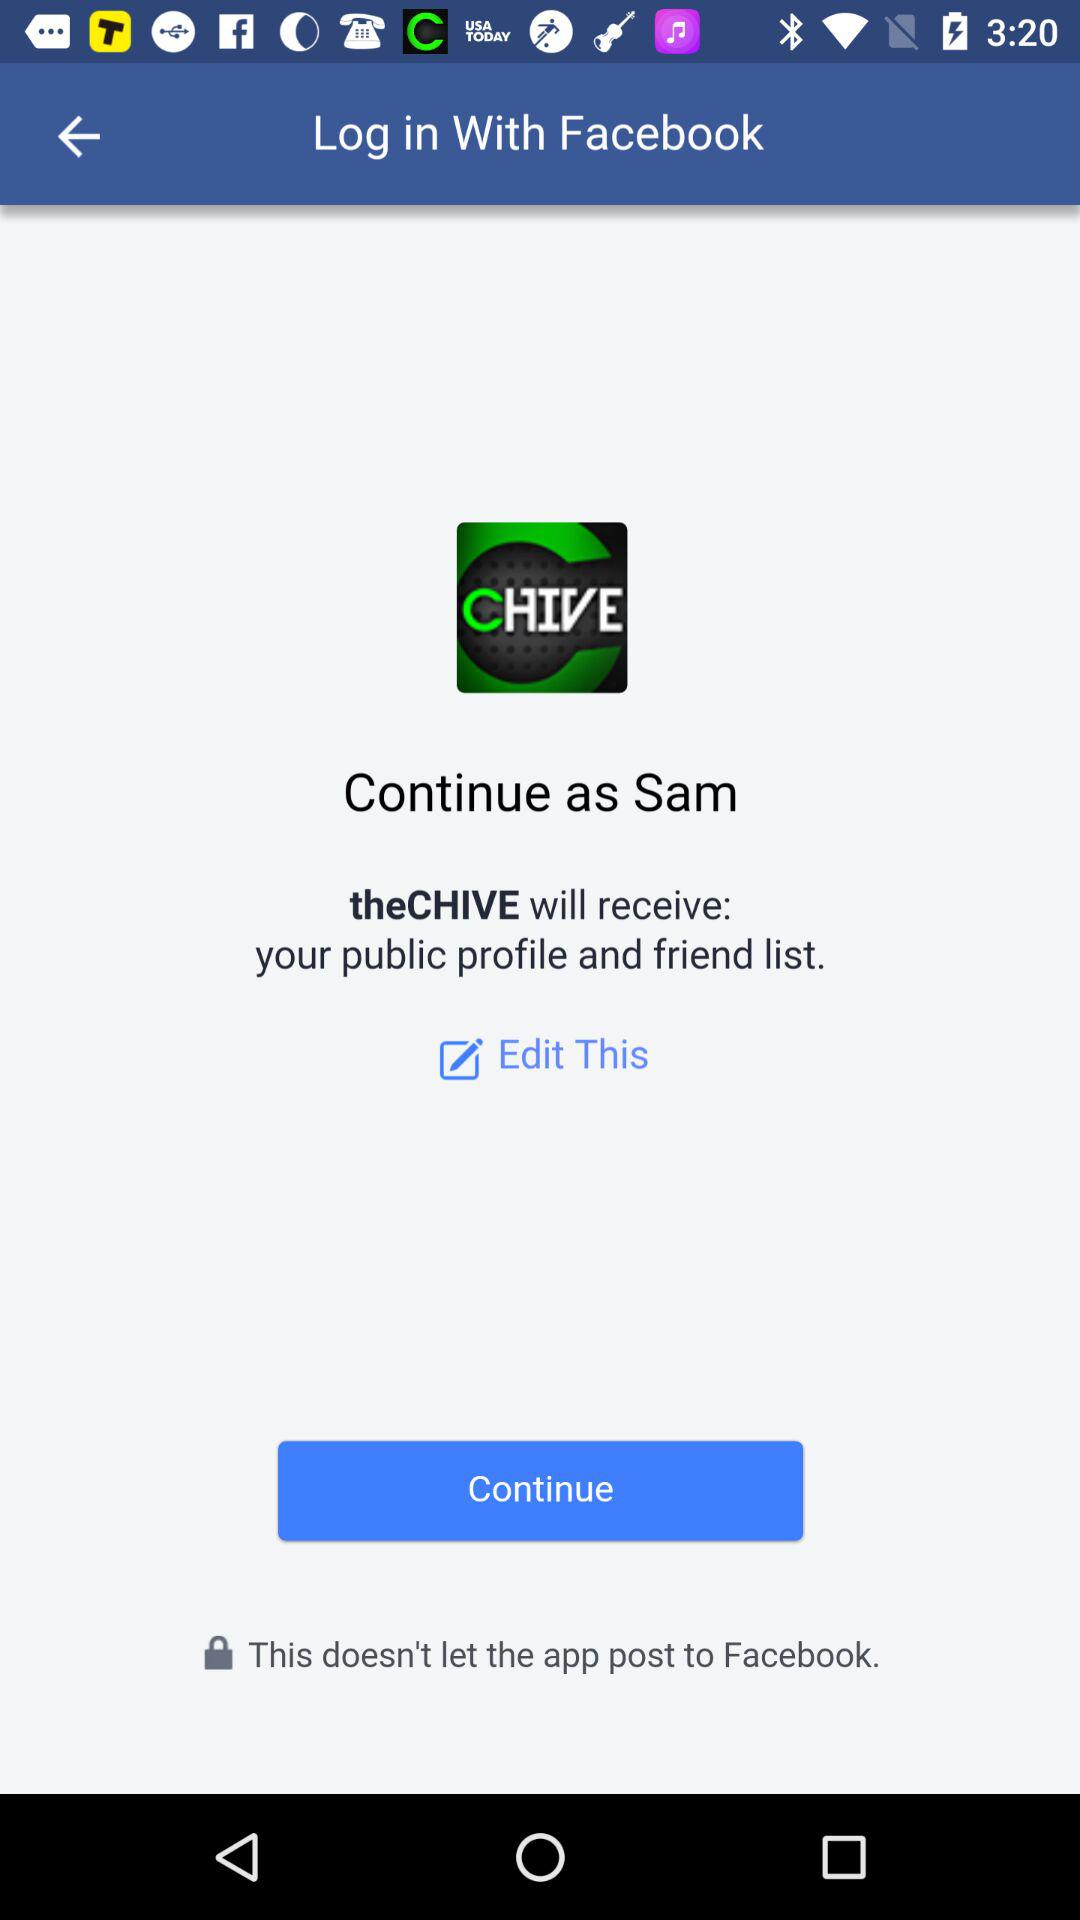What application will receive my public profile and friend list? The application "theCHIVE" will receive your public profile and friend list. 